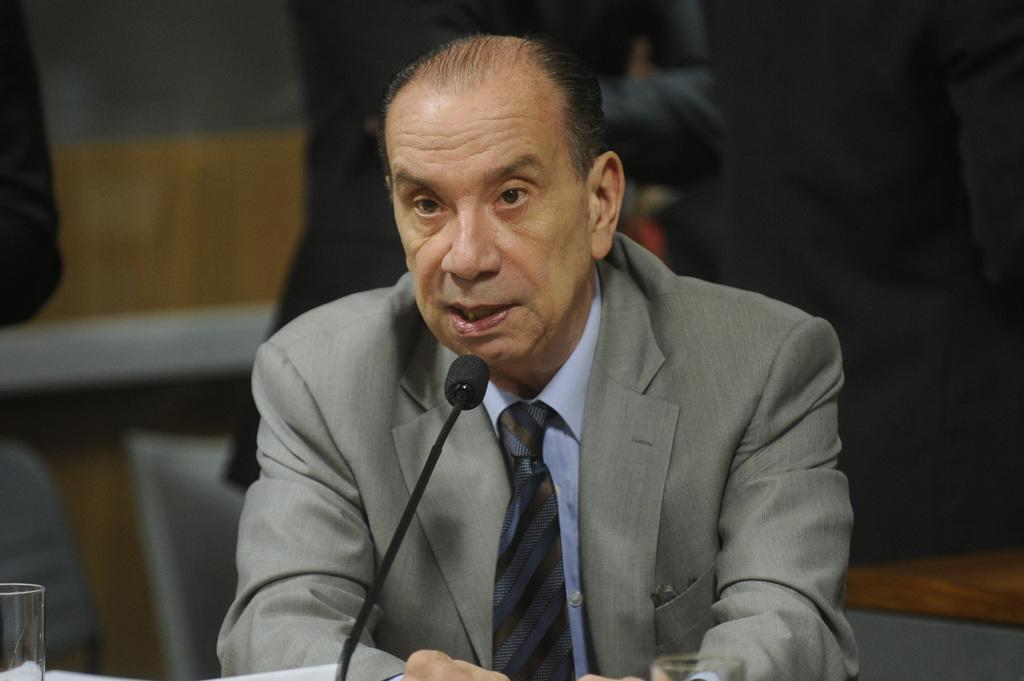Who is the main subject in the image? There is a person in the center of the image. What is the person wearing? The person is wearing a coat and a tie. What object can be seen near the person? There is a mic in the image. What is on a stand in the image? There is a glass on a stand in the image. What can be seen in the background of the image? There are people and a wall visible in the background of the image. Where is the toothbrush located in the image? There is no toothbrush present in the image. What is the person saying into the mic in the image? The image does not provide any information about what the person might be saying into the mic. 